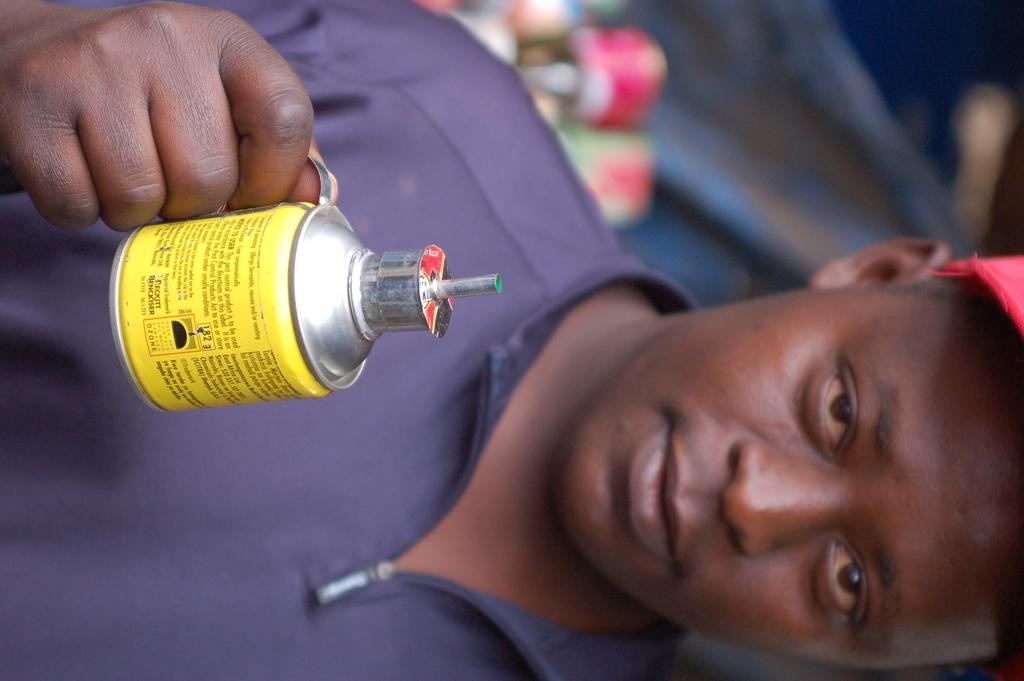What is present in the image? There is a man in the image. What is the man holding in his hand? The man is holding a container in his hand. What type of square object can be seen in the image? There is no square object present in the image. 